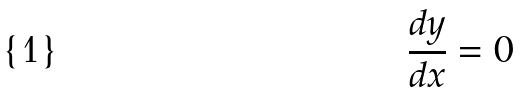<formula> <loc_0><loc_0><loc_500><loc_500>\frac { d y } { d x } = 0</formula> 